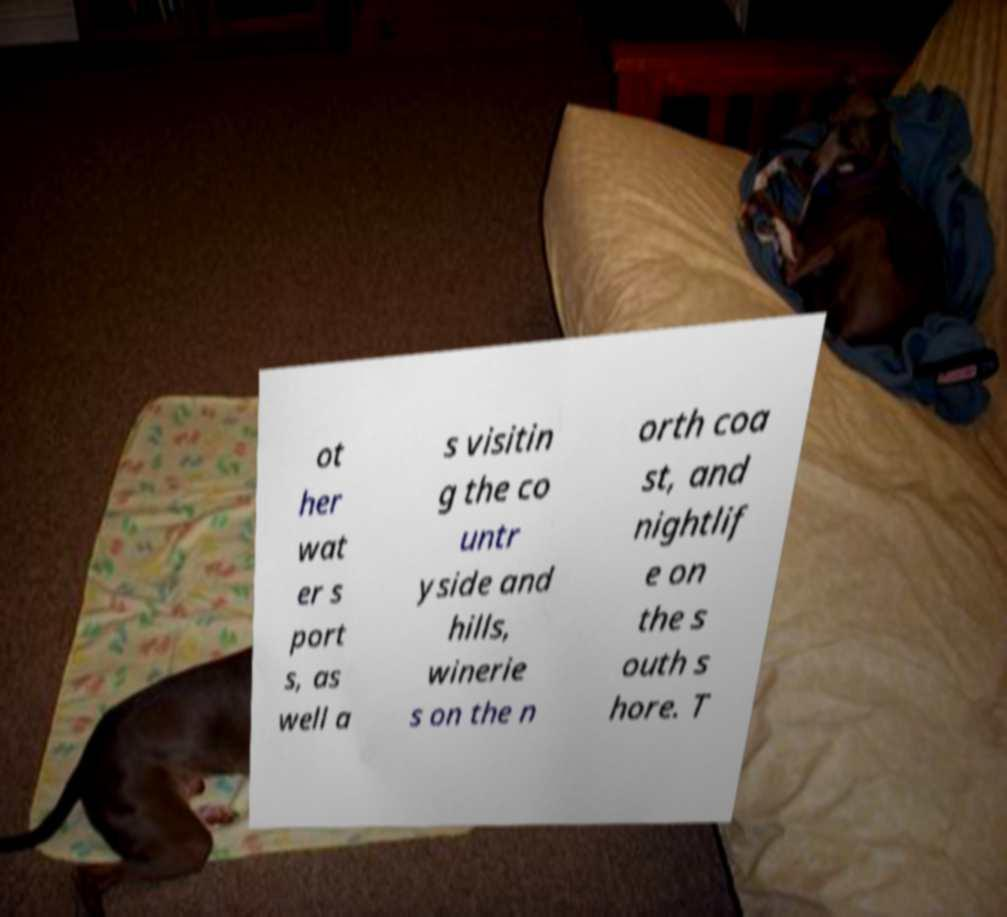Could you assist in decoding the text presented in this image and type it out clearly? ot her wat er s port s, as well a s visitin g the co untr yside and hills, winerie s on the n orth coa st, and nightlif e on the s outh s hore. T 